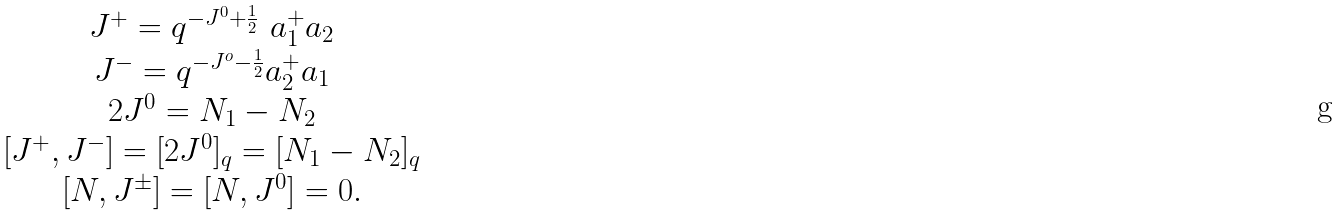<formula> <loc_0><loc_0><loc_500><loc_500>\begin{array} { c } J ^ { + } = q ^ { - J ^ { 0 } + \frac { 1 } { 2 } } \ a ^ { + } _ { 1 } a _ { 2 } \\ J ^ { - } = q ^ { - J ^ { o } - \frac { 1 } { 2 } } a ^ { + } _ { 2 } a _ { 1 } \\ 2 J ^ { 0 } = N _ { 1 } - N _ { 2 } \\ \left [ J ^ { + } , J ^ { - } \right ] = [ 2 J ^ { 0 } ] _ { q } = [ N _ { 1 } - N _ { 2 } ] _ { q } \\ \left [ N , J ^ { \pm } \right ] = [ N , J ^ { 0 } ] = 0 . \end{array}</formula> 